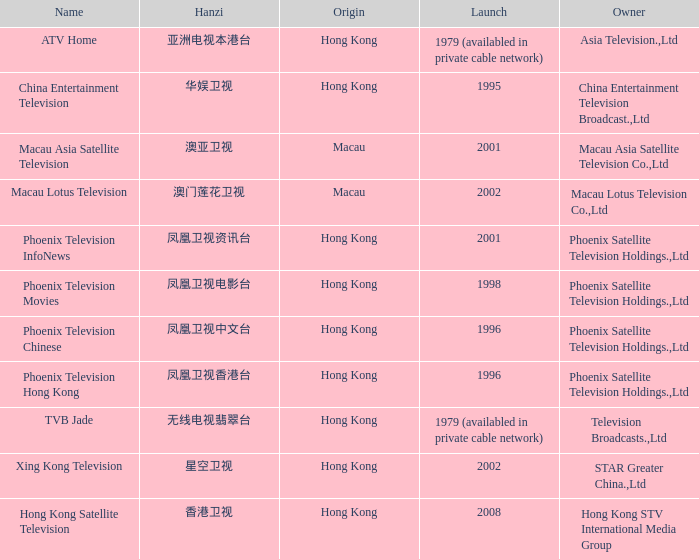Which company launched in 1996 and has a Hanzi of 凤凰卫视中文台? Phoenix Television Chinese. 